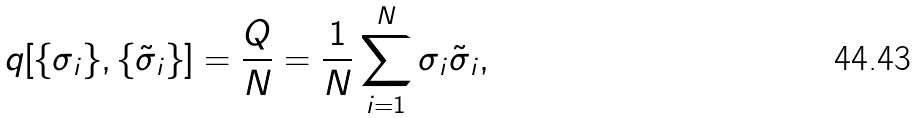<formula> <loc_0><loc_0><loc_500><loc_500>q [ \{ \sigma _ { i } \} , \{ \tilde { \sigma } _ { i } \} ] = \frac { Q } { N } = \frac { 1 } { N } \sum _ { i = 1 } ^ { N } \sigma _ { i } \tilde { \sigma } _ { i } ,</formula> 